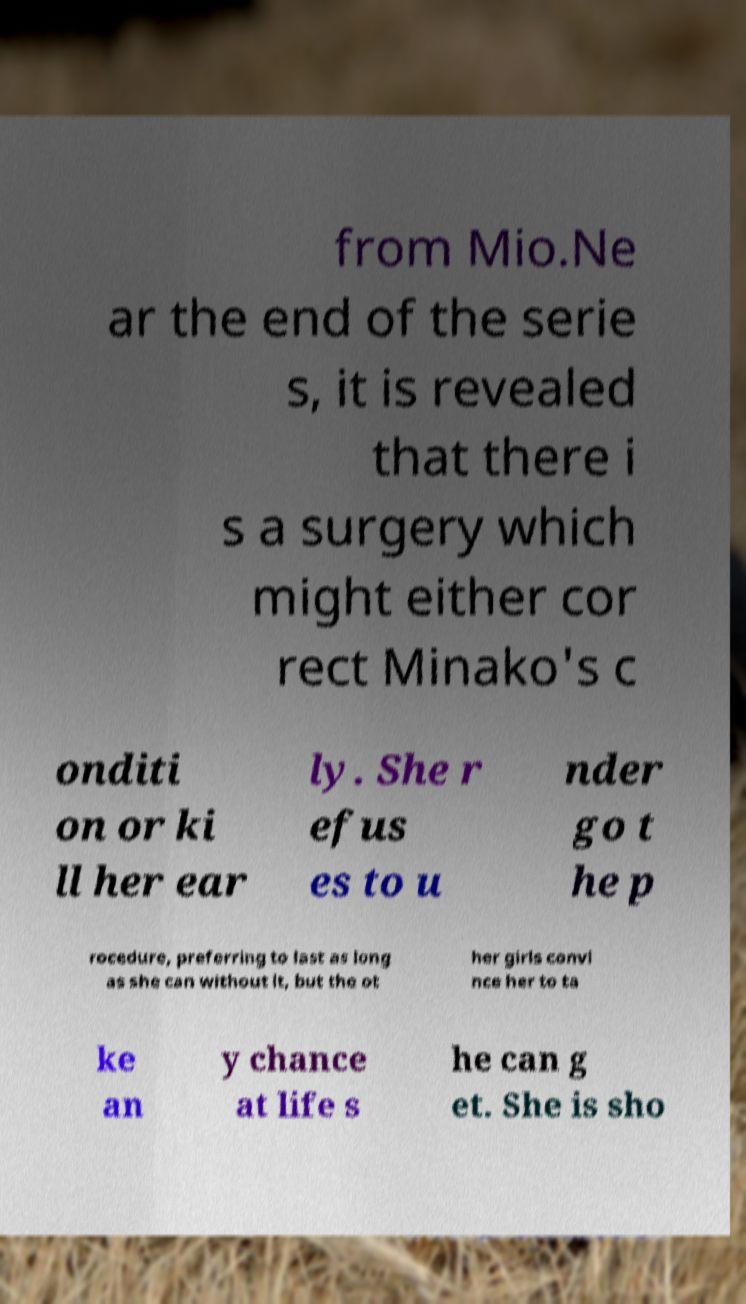Please read and relay the text visible in this image. What does it say? from Mio.Ne ar the end of the serie s, it is revealed that there i s a surgery which might either cor rect Minako's c onditi on or ki ll her ear ly. She r efus es to u nder go t he p rocedure, preferring to last as long as she can without it, but the ot her girls convi nce her to ta ke an y chance at life s he can g et. She is sho 